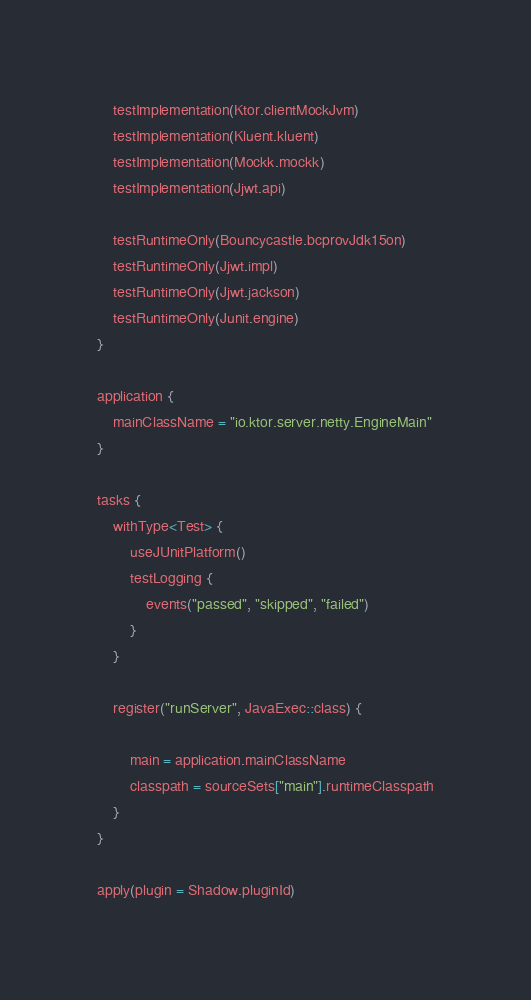<code> <loc_0><loc_0><loc_500><loc_500><_Kotlin_>    testImplementation(Ktor.clientMockJvm)
    testImplementation(Kluent.kluent)
    testImplementation(Mockk.mockk)
    testImplementation(Jjwt.api)

    testRuntimeOnly(Bouncycastle.bcprovJdk15on)
    testRuntimeOnly(Jjwt.impl)
    testRuntimeOnly(Jjwt.jackson)
    testRuntimeOnly(Junit.engine)
}

application {
    mainClassName = "io.ktor.server.netty.EngineMain"
}

tasks {
    withType<Test> {
        useJUnitPlatform()
        testLogging {
            events("passed", "skipped", "failed")
        }
    }

    register("runServer", JavaExec::class) {

        main = application.mainClassName
        classpath = sourceSets["main"].runtimeClasspath
    }
}

apply(plugin = Shadow.pluginId)
</code> 